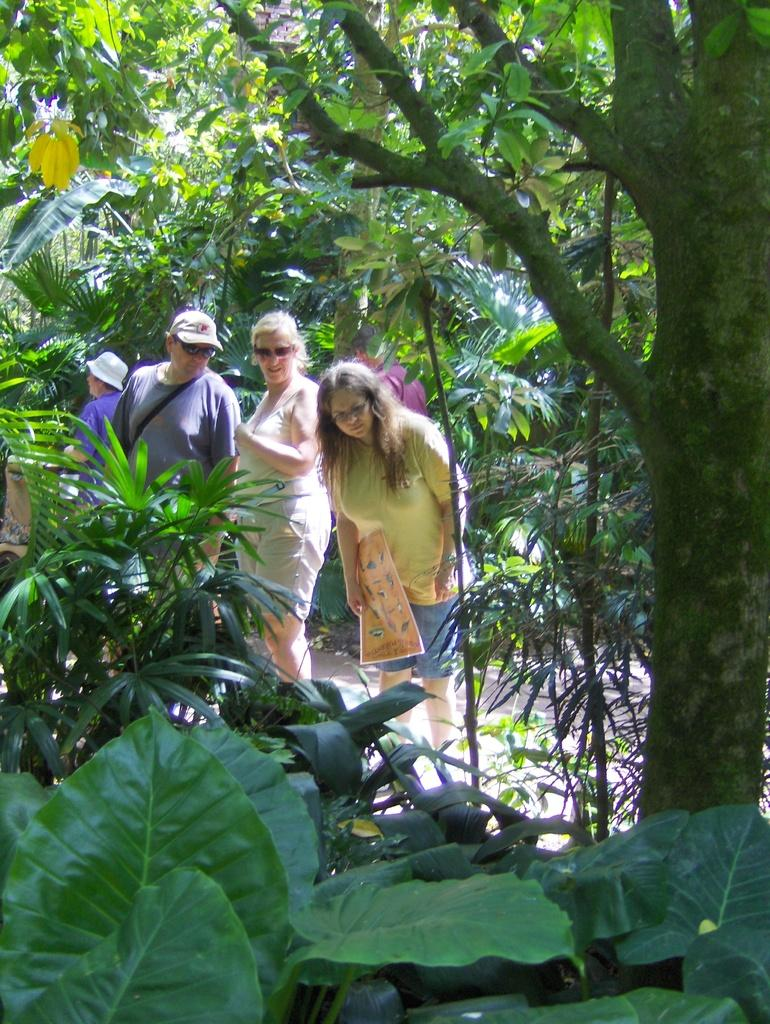What type of vegetation can be seen in the image? There are many plants and trees in the image. How many people are present in the image? There are four persons in the image. What is the lady in the image doing? A lady is holding an object in the image. Can you tell me what type of suggestion the wren is making in the image? There is no wren present in the image, so it is not possible to determine what type of suggestion it might be making. 